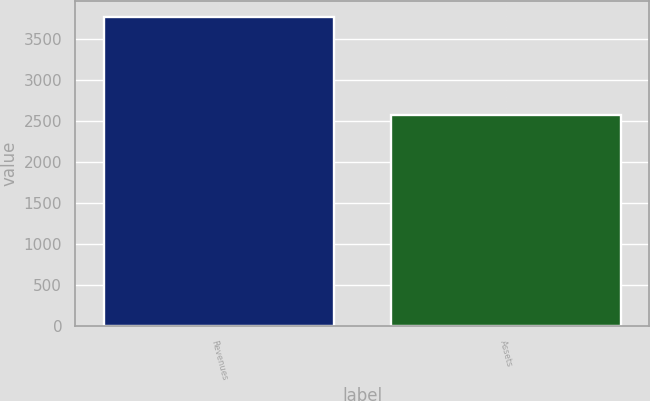<chart> <loc_0><loc_0><loc_500><loc_500><bar_chart><fcel>Revenues<fcel>Assets<nl><fcel>3771.9<fcel>2579.1<nl></chart> 